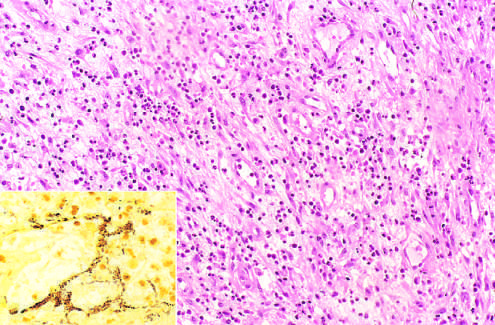what demonstrates clusters of tangled bacilli (black)?
Answer the question using a single word or phrase. Modified silver (warthin-starry) stain 